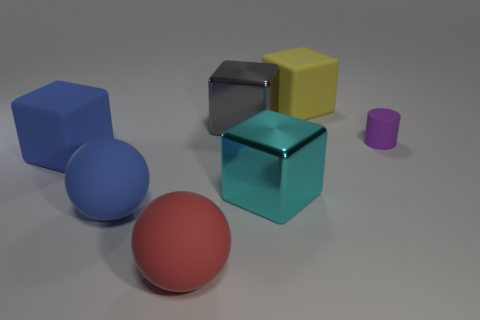Subtract all large cyan blocks. How many blocks are left? 3 Subtract 2 blocks. How many blocks are left? 2 Subtract all blocks. How many objects are left? 3 Add 3 brown objects. How many objects exist? 10 Subtract all blue blocks. How many blocks are left? 3 Subtract all yellow blocks. Subtract all purple spheres. How many blocks are left? 3 Add 4 large blue rubber balls. How many large blue rubber balls are left? 5 Add 7 rubber cylinders. How many rubber cylinders exist? 8 Subtract 0 cyan cylinders. How many objects are left? 7 Subtract all blue rubber blocks. Subtract all blue rubber cubes. How many objects are left? 5 